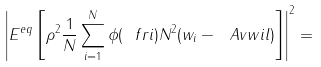<formula> <loc_0><loc_0><loc_500><loc_500>\left | E ^ { e q } \left [ \rho ^ { 2 } \frac { 1 } { N } \sum _ { i = 1 } ^ { N } \phi ( \ f r i ) N ^ { 2 } ( w _ { i } - \ A v { w } { i } { l } ) \right ] \right | ^ { 2 } =</formula> 